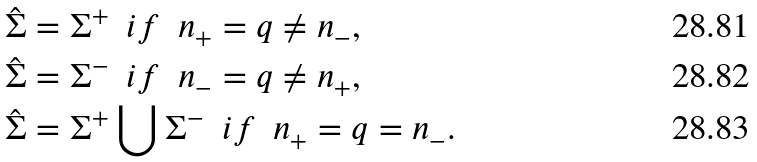<formula> <loc_0><loc_0><loc_500><loc_500>& \hat { \Sigma } = \Sigma ^ { + } \ \ i f \ \ n _ { + } = q \neq n _ { - } , \\ & \hat { \Sigma } = \Sigma ^ { - } \ \ i f \ \ n _ { - } = q \neq n _ { + } , \\ & \hat { \Sigma } = \Sigma ^ { + } \bigcup \Sigma ^ { - } \ \ i f \ \ n _ { + } = q = n _ { - } .</formula> 